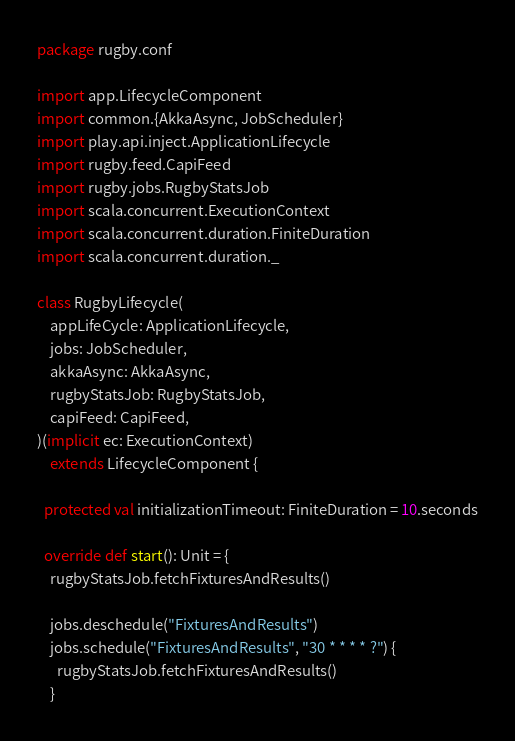Convert code to text. <code><loc_0><loc_0><loc_500><loc_500><_Scala_>package rugby.conf

import app.LifecycleComponent
import common.{AkkaAsync, JobScheduler}
import play.api.inject.ApplicationLifecycle
import rugby.feed.CapiFeed
import rugby.jobs.RugbyStatsJob
import scala.concurrent.ExecutionContext
import scala.concurrent.duration.FiniteDuration
import scala.concurrent.duration._

class RugbyLifecycle(
    appLifeCycle: ApplicationLifecycle,
    jobs: JobScheduler,
    akkaAsync: AkkaAsync,
    rugbyStatsJob: RugbyStatsJob,
    capiFeed: CapiFeed,
)(implicit ec: ExecutionContext)
    extends LifecycleComponent {

  protected val initializationTimeout: FiniteDuration = 10.seconds

  override def start(): Unit = {
    rugbyStatsJob.fetchFixturesAndResults()

    jobs.deschedule("FixturesAndResults")
    jobs.schedule("FixturesAndResults", "30 * * * * ?") {
      rugbyStatsJob.fetchFixturesAndResults()
    }
</code> 